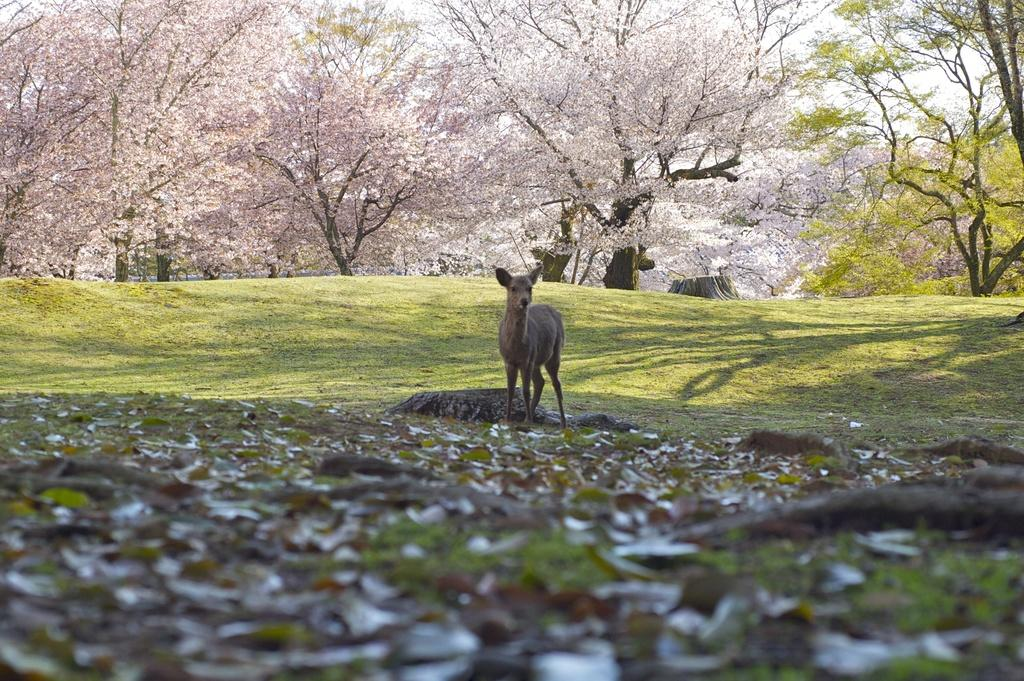What type of animal can be seen in the image? There is a deer in the image. What is on the ground in the image? Dried leaves are present on the ground. What type of vegetation is visible in the image? There is green grass in the image. What can be seen in the background of the image? Trees with pink color leaves are visible in the background. What type of pancake is being served to the deer in the image? There is no pancake present in the image, and the deer is not being served any food. 